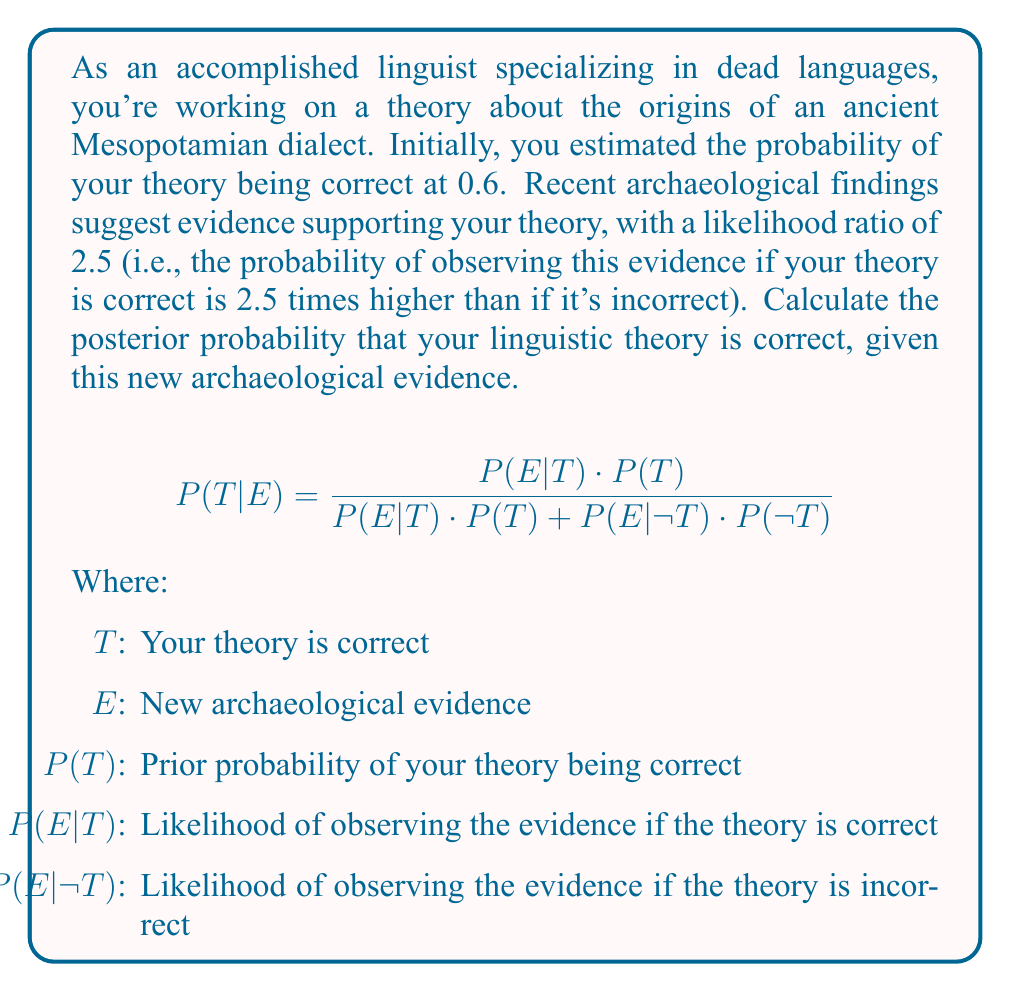Could you help me with this problem? Let's solve this problem step-by-step using Bayes' theorem:

1. Given information:
   - Prior probability, $P(T) = 0.6$
   - Likelihood ratio, $LR = \frac{P(E|T)}{P(E|\neg T)} = 2.5$

2. Calculate $P(\neg T)$:
   $P(\neg T) = 1 - P(T) = 1 - 0.6 = 0.4$

3. Set up the likelihood ratio equation:
   $\frac{P(E|T)}{P(E|\neg T)} = 2.5$

4. Assume $P(E|\neg T) = 1$ for simplicity. Then:
   $P(E|T) = 2.5 \cdot P(E|\neg T) = 2.5 \cdot 1 = 2.5$

5. Apply Bayes' theorem:
   $$P(T|E) = \frac{P(E|T) \cdot P(T)}{P(E|T) \cdot P(T) + P(E|\neg T) \cdot P(\neg T)}$$

6. Substitute the values:
   $$P(T|E) = \frac{2.5 \cdot 0.6}{2.5 \cdot 0.6 + 1 \cdot 0.4}$$

7. Calculate:
   $$P(T|E) = \frac{1.5}{1.5 + 0.4} = \frac{1.5}{1.9} \approx 0.7895$$

Therefore, the posterior probability that your linguistic theory is correct, given the new archaeological evidence, is approximately 0.7895 or 78.95%.
Answer: $P(T|E) \approx 0.7895$ 